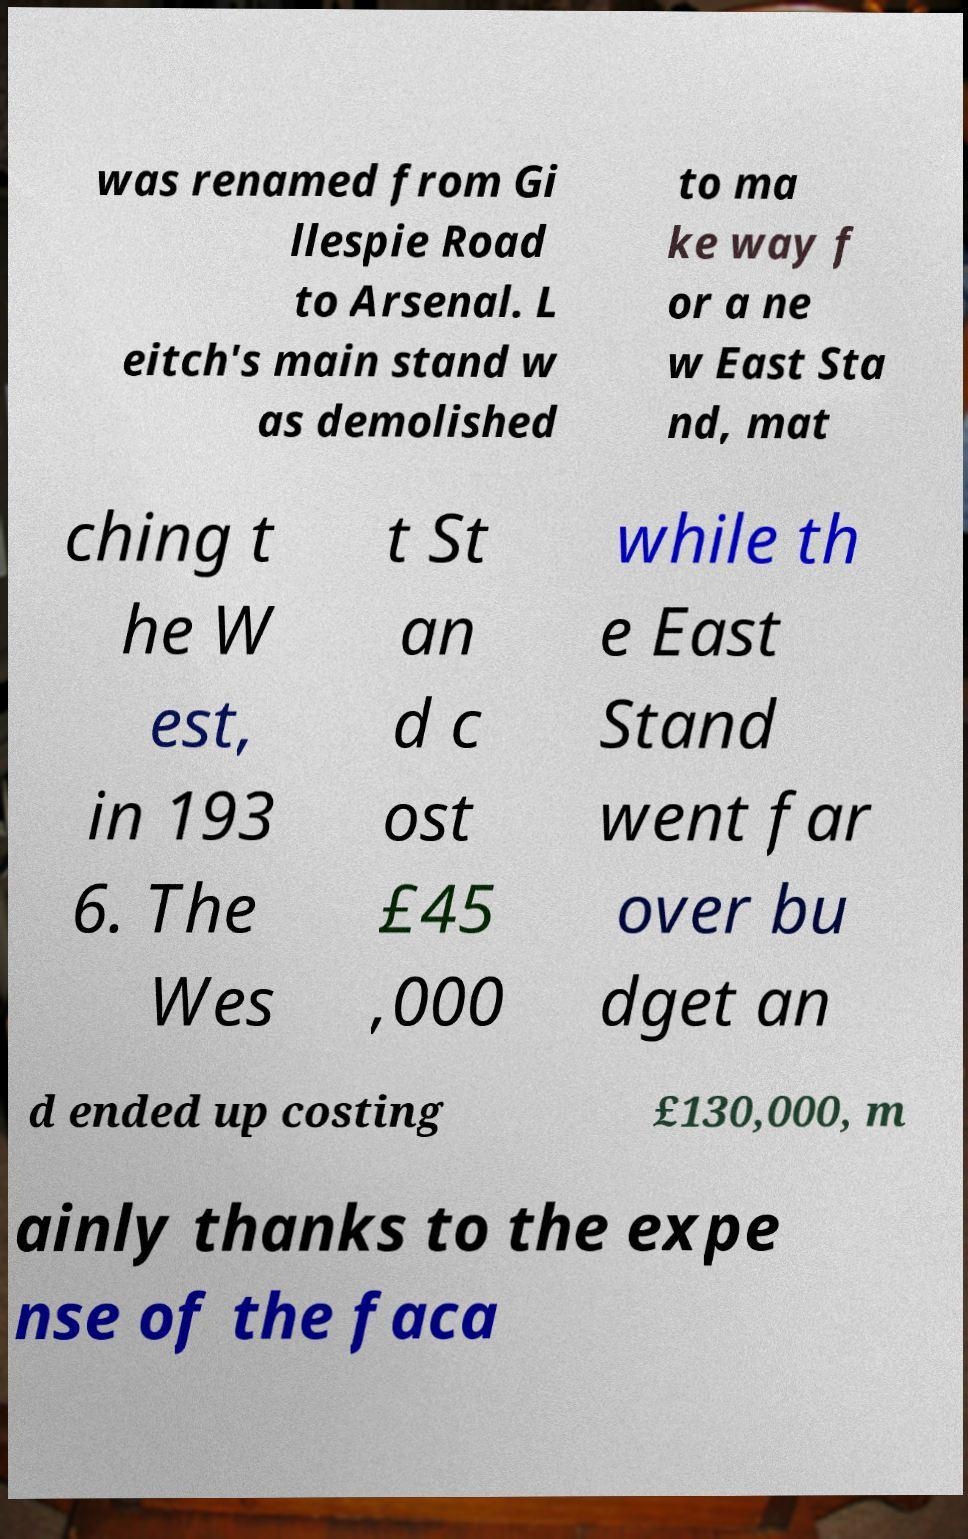Please read and relay the text visible in this image. What does it say? was renamed from Gi llespie Road to Arsenal. L eitch's main stand w as demolished to ma ke way f or a ne w East Sta nd, mat ching t he W est, in 193 6. The Wes t St an d c ost £45 ,000 while th e East Stand went far over bu dget an d ended up costing £130,000, m ainly thanks to the expe nse of the faca 